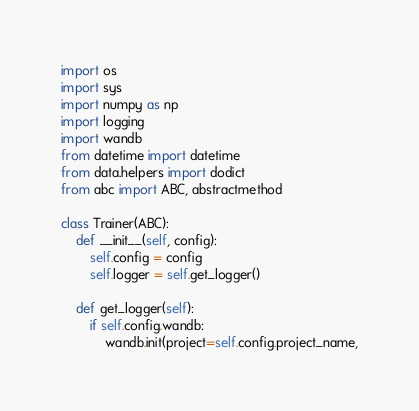Convert code to text. <code><loc_0><loc_0><loc_500><loc_500><_Python_>import os
import sys
import numpy as np
import logging
import wandb
from datetime import datetime
from data.helpers import dodict
from abc import ABC, abstractmethod

class Trainer(ABC):
    def __init__(self, config):
        self.config = config
        self.logger = self.get_logger()

    def get_logger(self):
        if self.config.wandb:
            wandb.init(project=self.config.project_name,</code> 